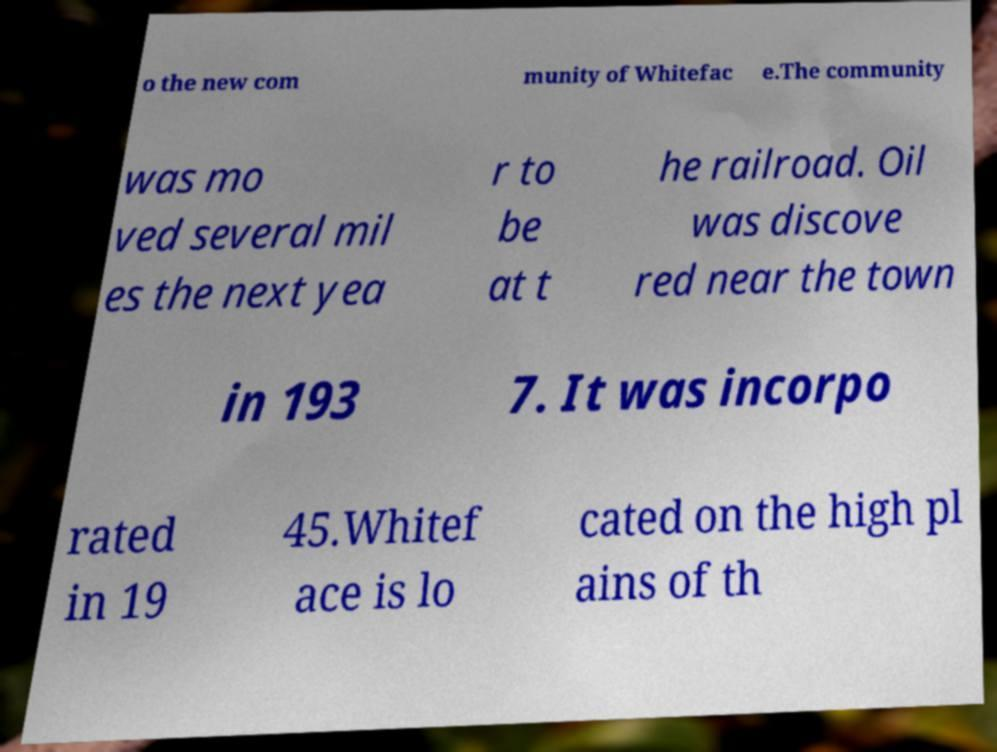For documentation purposes, I need the text within this image transcribed. Could you provide that? o the new com munity of Whitefac e.The community was mo ved several mil es the next yea r to be at t he railroad. Oil was discove red near the town in 193 7. It was incorpo rated in 19 45.Whitef ace is lo cated on the high pl ains of th 